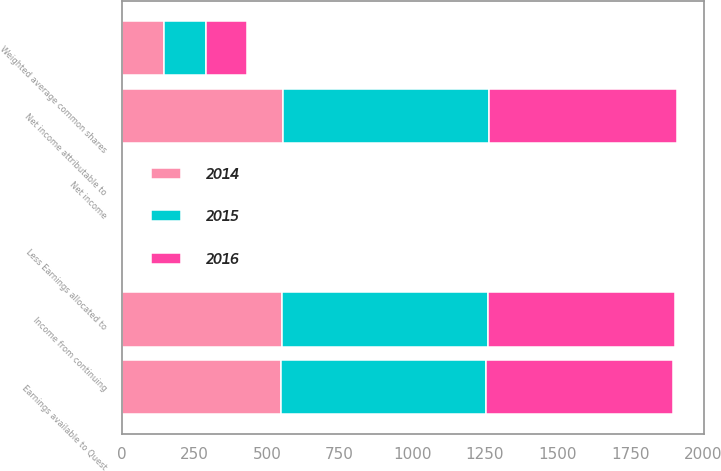<chart> <loc_0><loc_0><loc_500><loc_500><stacked_bar_chart><ecel><fcel>Income from continuing<fcel>Net income attributable to<fcel>Less Earnings allocated to<fcel>Earnings available to Quest<fcel>Weighted average common shares<fcel>Net income<nl><fcel>2016<fcel>645<fcel>645<fcel>3<fcel>642<fcel>142<fcel>4.58<nl><fcel>2015<fcel>709<fcel>709<fcel>3<fcel>706<fcel>145<fcel>4.92<nl><fcel>2014<fcel>551<fcel>556<fcel>2<fcel>549<fcel>145<fcel>3.83<nl></chart> 